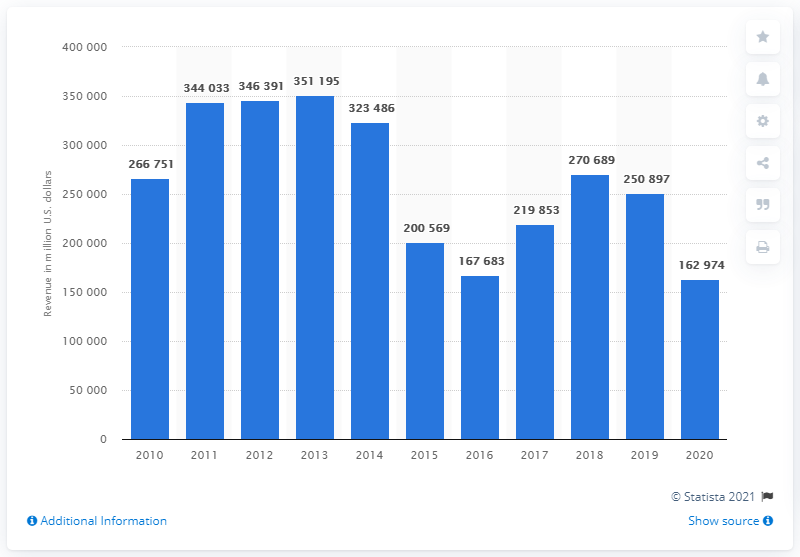List a handful of essential elements in this visual. BP's Downstream business segment generated a revenue of 162,974 in 2020. 